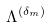Convert formula to latex. <formula><loc_0><loc_0><loc_500><loc_500>\Lambda ^ { ( \delta _ { m } ) }</formula> 